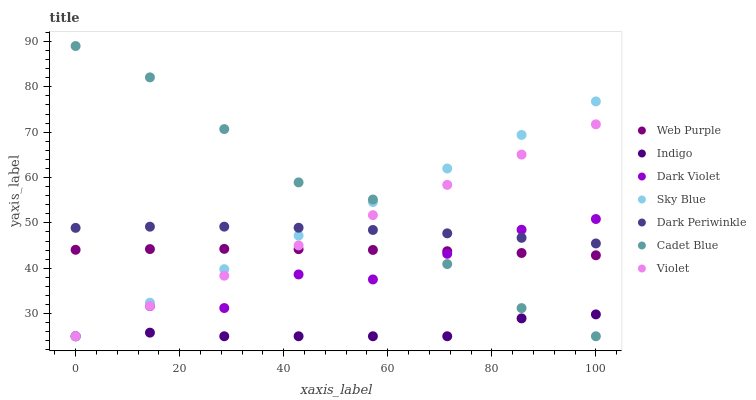Does Indigo have the minimum area under the curve?
Answer yes or no. Yes. Does Cadet Blue have the maximum area under the curve?
Answer yes or no. Yes. Does Dark Violet have the minimum area under the curve?
Answer yes or no. No. Does Dark Violet have the maximum area under the curve?
Answer yes or no. No. Is Violet the smoothest?
Answer yes or no. Yes. Is Dark Violet the roughest?
Answer yes or no. Yes. Is Indigo the smoothest?
Answer yes or no. No. Is Indigo the roughest?
Answer yes or no. No. Does Cadet Blue have the lowest value?
Answer yes or no. Yes. Does Web Purple have the lowest value?
Answer yes or no. No. Does Cadet Blue have the highest value?
Answer yes or no. Yes. Does Dark Violet have the highest value?
Answer yes or no. No. Is Indigo less than Web Purple?
Answer yes or no. Yes. Is Dark Periwinkle greater than Indigo?
Answer yes or no. Yes. Does Web Purple intersect Sky Blue?
Answer yes or no. Yes. Is Web Purple less than Sky Blue?
Answer yes or no. No. Is Web Purple greater than Sky Blue?
Answer yes or no. No. Does Indigo intersect Web Purple?
Answer yes or no. No. 